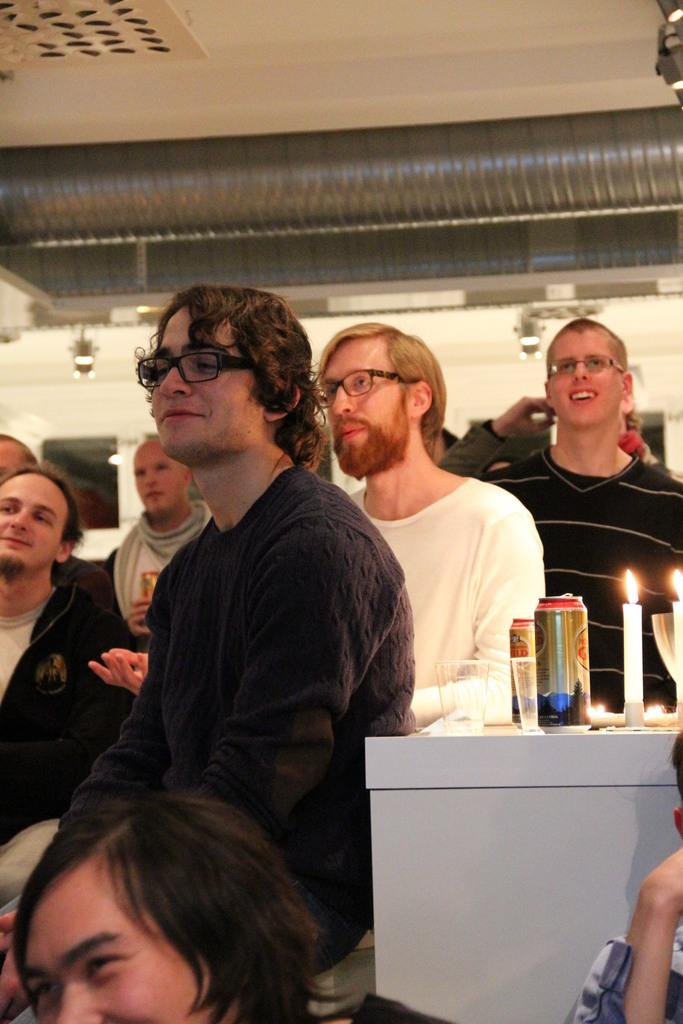How many people are in the image? There is a group of people in the image. What objects can be seen in the image besides the people? There are tins, glasses, candles, and spectacles in the image. What can be seen in the background of the image? There is a wall, a ceiling, lights, and some objects in the background of the image. What type of treatment is being administered in the image? There is no indication of any treatment being administered in the image. --- Facts: 1. There is a group of people in the image. 12. There are tins in the image. 13. There are glasses in the image. 14. There are candles in the image. 15. There are spectacles in the image. 16. There is a wall in the background of the image. 17. There is a ceiling in the background of the image. 18. There are lights in the background of the image. 19. There are some objects in the background of the image. Absurd Topics: treatment, waves, carpenter Conversation: How many people are in the image? There is a group of people in the image. What objects can be seen in the image besides the people? There are tins, glasses, candles, and spectacles in the image. What can be seen in the background of the image? There is a wall, a ceiling, lights, and some objects in the background of the image. Reasoning: Let's think step by step in order to produce the conversation. We start by identifying the main subject in the image, which is the group of people. Then, we expand the conversation to include other items that are also visible, such as tins, glasses, candles, and spectacles. We also describe the background of the image, mentioning the wall, ceiling, lights, and other objects. Each question is designed to elicit a specific detail about the image that is known from the provided facts. Absurd Question/Answer: What type of waves can be seen in the image? There are no waves visible in the image. --- Facts: 11. There is a group of people in the image. 112. There are tins in the image. 113. There are glasses in the image. 114. There are candles in the image. 115. There are spectacles in the image. 116. There is a wall in the background of the image. 117. There is a ceiling in the background of the image. 118. There are lights in the background of the image. 119. There are some objects in the background of the image. Absurd Topics: treatment, waves, carpenter Conversation: 